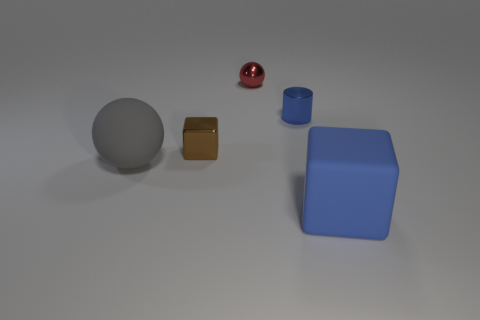Add 2 large gray balls. How many objects exist? 7 Subtract all gray balls. How many balls are left? 1 Subtract all big purple metal balls. Subtract all tiny blue cylinders. How many objects are left? 4 Add 3 big gray matte things. How many big gray matte things are left? 4 Add 4 tiny purple spheres. How many tiny purple spheres exist? 4 Subtract 1 gray spheres. How many objects are left? 4 Subtract all cubes. How many objects are left? 3 Subtract 1 spheres. How many spheres are left? 1 Subtract all purple spheres. Subtract all brown cylinders. How many spheres are left? 2 Subtract all red balls. How many red cylinders are left? 0 